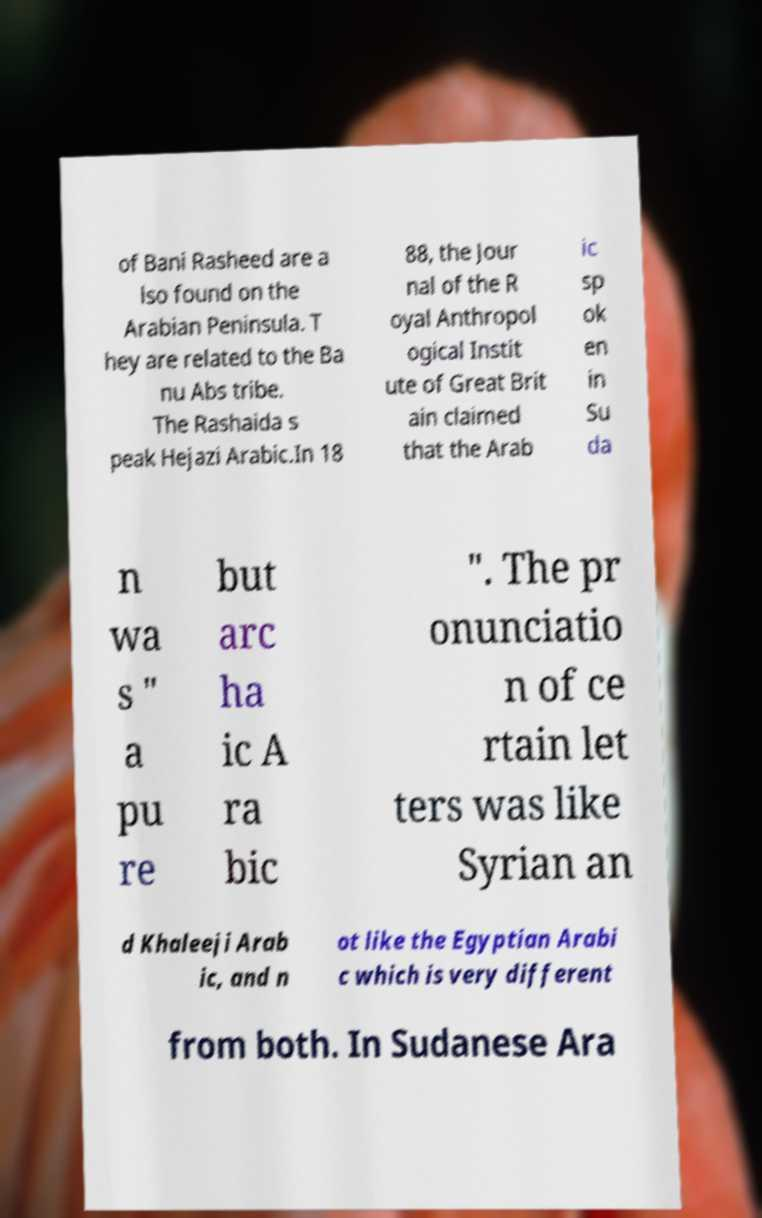For documentation purposes, I need the text within this image transcribed. Could you provide that? of Bani Rasheed are a lso found on the Arabian Peninsula. T hey are related to the Ba nu Abs tribe. The Rashaida s peak Hejazi Arabic.In 18 88, the Jour nal of the R oyal Anthropol ogical Instit ute of Great Brit ain claimed that the Arab ic sp ok en in Su da n wa s " a pu re but arc ha ic A ra bic ". The pr onunciatio n of ce rtain let ters was like Syrian an d Khaleeji Arab ic, and n ot like the Egyptian Arabi c which is very different from both. In Sudanese Ara 